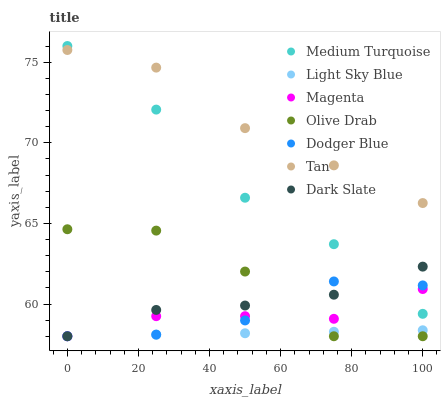Does Light Sky Blue have the minimum area under the curve?
Answer yes or no. Yes. Does Tan have the maximum area under the curve?
Answer yes or no. Yes. Does Dodger Blue have the minimum area under the curve?
Answer yes or no. No. Does Dodger Blue have the maximum area under the curve?
Answer yes or no. No. Is Light Sky Blue the smoothest?
Answer yes or no. Yes. Is Olive Drab the roughest?
Answer yes or no. Yes. Is Dodger Blue the smoothest?
Answer yes or no. No. Is Dodger Blue the roughest?
Answer yes or no. No. Does Dark Slate have the lowest value?
Answer yes or no. Yes. Does Medium Turquoise have the lowest value?
Answer yes or no. No. Does Medium Turquoise have the highest value?
Answer yes or no. Yes. Does Dodger Blue have the highest value?
Answer yes or no. No. Is Dark Slate less than Tan?
Answer yes or no. Yes. Is Tan greater than Dodger Blue?
Answer yes or no. Yes. Does Magenta intersect Light Sky Blue?
Answer yes or no. Yes. Is Magenta less than Light Sky Blue?
Answer yes or no. No. Is Magenta greater than Light Sky Blue?
Answer yes or no. No. Does Dark Slate intersect Tan?
Answer yes or no. No. 